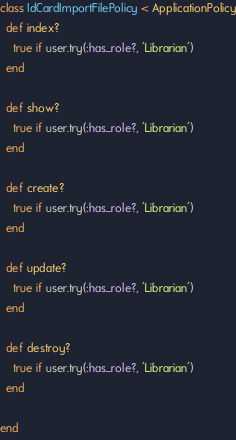Convert code to text. <code><loc_0><loc_0><loc_500><loc_500><_Ruby_>class IdCardImportFilePolicy < ApplicationPolicy
  def index?
    true if user.try(:has_role?, 'Librarian')
  end

  def show?
    true if user.try(:has_role?, 'Librarian')
  end

  def create?
    true if user.try(:has_role?, 'Librarian')
  end

  def update?
    true if user.try(:has_role?, 'Librarian')
  end

  def destroy?
    true if user.try(:has_role?, 'Librarian')
  end

end</code> 